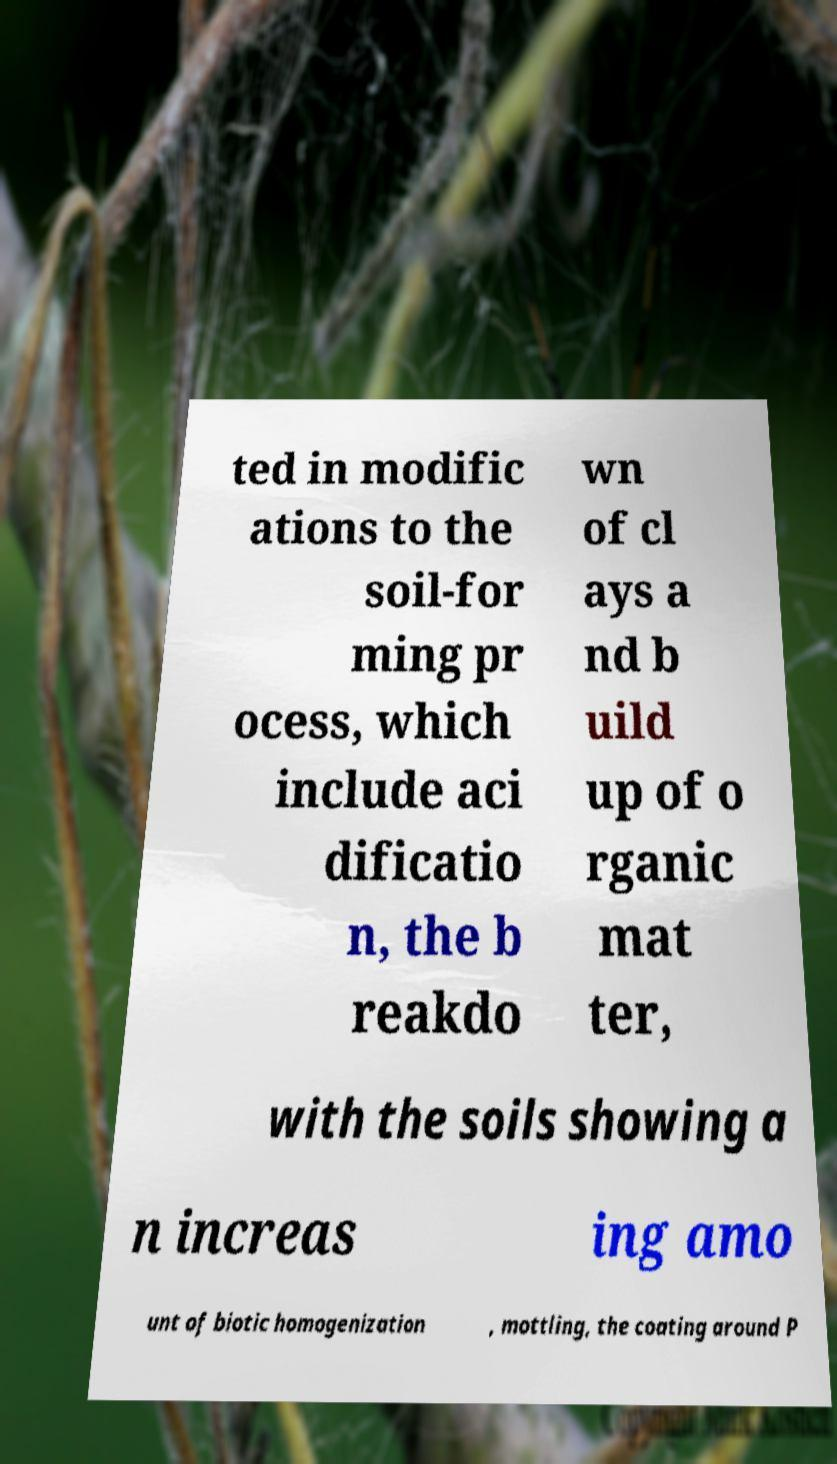Can you accurately transcribe the text from the provided image for me? ted in modific ations to the soil-for ming pr ocess, which include aci dificatio n, the b reakdo wn of cl ays a nd b uild up of o rganic mat ter, with the soils showing a n increas ing amo unt of biotic homogenization , mottling, the coating around P 